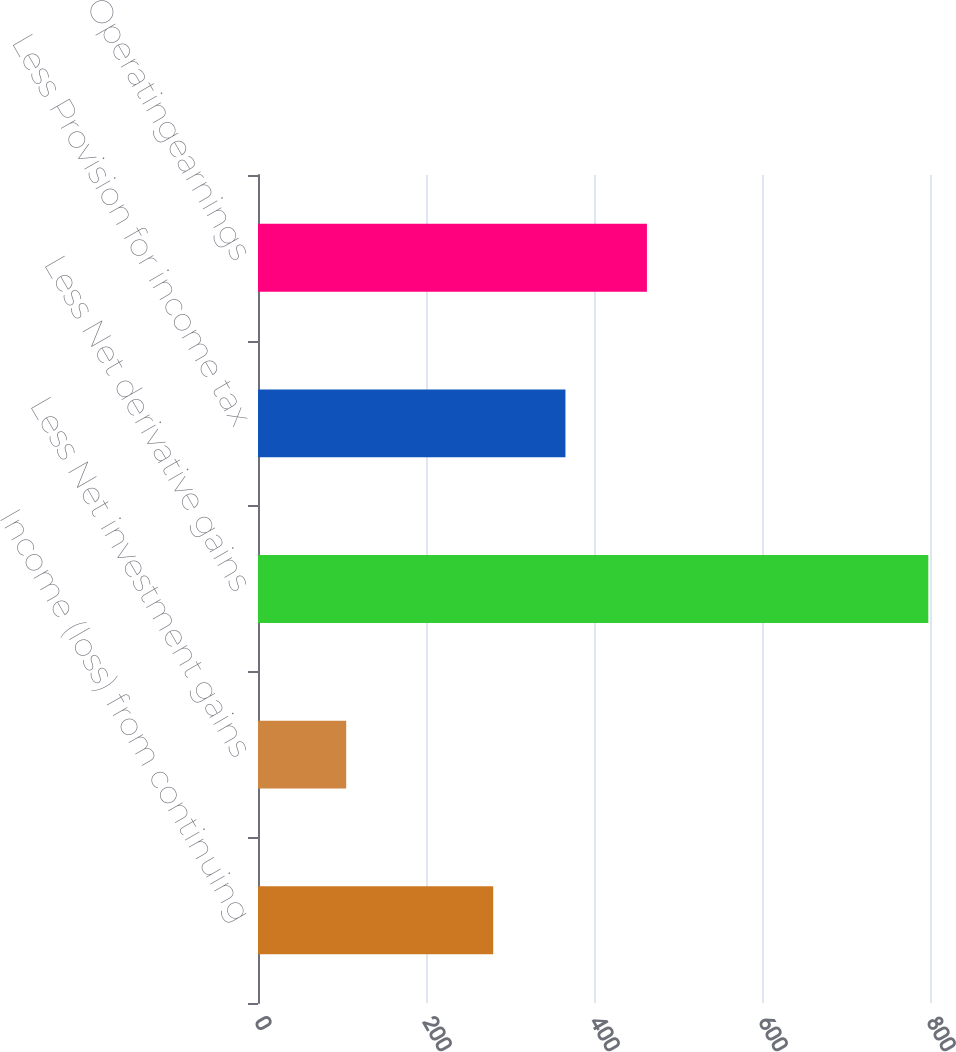Convert chart. <chart><loc_0><loc_0><loc_500><loc_500><bar_chart><fcel>Income (loss) from continuing<fcel>Less Net investment gains<fcel>Less Net derivative gains<fcel>Less Provision for income tax<fcel>Operatingearnings<nl><fcel>280<fcel>105<fcel>798<fcel>366<fcel>463<nl></chart> 